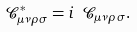<formula> <loc_0><loc_0><loc_500><loc_500>\mathcal { C } ^ { * } _ { \mu \nu \rho \sigma } = i \ \mathcal { C } _ { \mu \nu \rho \sigma } .</formula> 